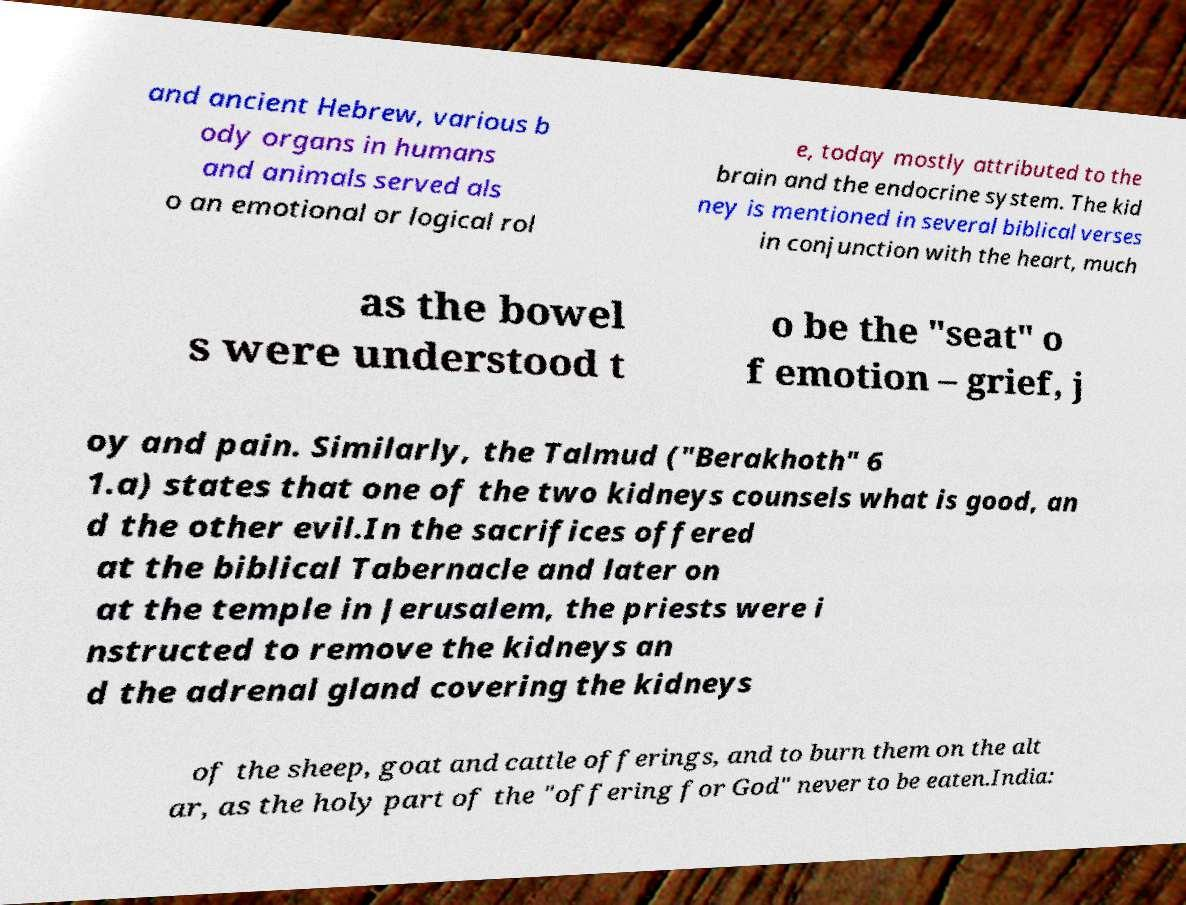Please identify and transcribe the text found in this image. and ancient Hebrew, various b ody organs in humans and animals served als o an emotional or logical rol e, today mostly attributed to the brain and the endocrine system. The kid ney is mentioned in several biblical verses in conjunction with the heart, much as the bowel s were understood t o be the "seat" o f emotion – grief, j oy and pain. Similarly, the Talmud ("Berakhoth" 6 1.a) states that one of the two kidneys counsels what is good, an d the other evil.In the sacrifices offered at the biblical Tabernacle and later on at the temple in Jerusalem, the priests were i nstructed to remove the kidneys an d the adrenal gland covering the kidneys of the sheep, goat and cattle offerings, and to burn them on the alt ar, as the holy part of the "offering for God" never to be eaten.India: 